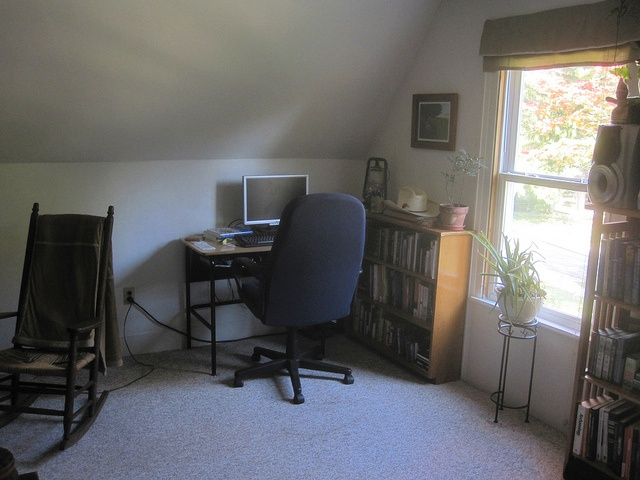Describe the objects in this image and their specific colors. I can see book in gray and black tones, chair in gray and black tones, chair in gray and black tones, potted plant in gray, darkgray, and white tones, and tv in gray, black, darkgray, and lightblue tones in this image. 